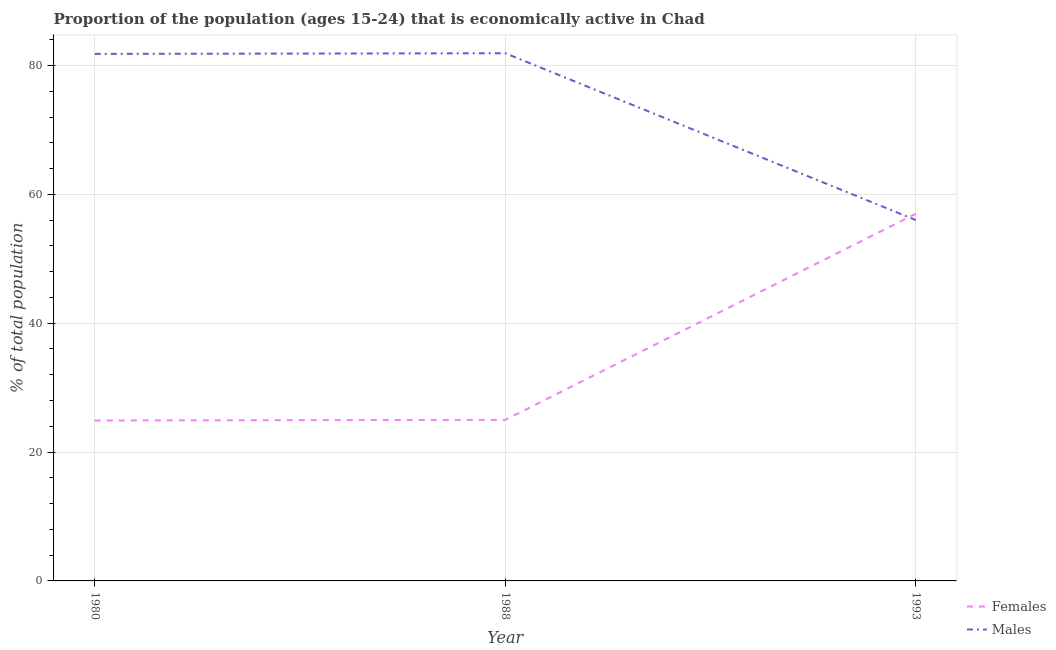Is the number of lines equal to the number of legend labels?
Provide a short and direct response. Yes. What is the percentage of economically active male population in 1980?
Offer a very short reply. 81.8. Across all years, what is the maximum percentage of economically active male population?
Provide a short and direct response. 81.9. Across all years, what is the minimum percentage of economically active male population?
Your response must be concise. 56. In which year was the percentage of economically active female population maximum?
Ensure brevity in your answer.  1993. In which year was the percentage of economically active male population minimum?
Keep it short and to the point. 1993. What is the total percentage of economically active male population in the graph?
Offer a terse response. 219.7. What is the difference between the percentage of economically active male population in 1980 and that in 1993?
Your answer should be very brief. 25.8. What is the difference between the percentage of economically active male population in 1980 and the percentage of economically active female population in 1993?
Offer a very short reply. 24.8. What is the average percentage of economically active female population per year?
Provide a short and direct response. 35.63. In how many years, is the percentage of economically active male population greater than 20 %?
Provide a short and direct response. 3. What is the ratio of the percentage of economically active male population in 1988 to that in 1993?
Provide a succinct answer. 1.46. What is the difference between the highest and the second highest percentage of economically active female population?
Ensure brevity in your answer.  32. What is the difference between the highest and the lowest percentage of economically active female population?
Your response must be concise. 32.1. In how many years, is the percentage of economically active female population greater than the average percentage of economically active female population taken over all years?
Offer a terse response. 1. Is the sum of the percentage of economically active female population in 1988 and 1993 greater than the maximum percentage of economically active male population across all years?
Offer a terse response. Yes. Does the percentage of economically active female population monotonically increase over the years?
Your answer should be compact. Yes. How many years are there in the graph?
Give a very brief answer. 3. What is the difference between two consecutive major ticks on the Y-axis?
Ensure brevity in your answer.  20. Are the values on the major ticks of Y-axis written in scientific E-notation?
Offer a very short reply. No. Does the graph contain grids?
Make the answer very short. Yes. How are the legend labels stacked?
Provide a short and direct response. Vertical. What is the title of the graph?
Offer a very short reply. Proportion of the population (ages 15-24) that is economically active in Chad. What is the label or title of the X-axis?
Ensure brevity in your answer.  Year. What is the label or title of the Y-axis?
Give a very brief answer. % of total population. What is the % of total population in Females in 1980?
Give a very brief answer. 24.9. What is the % of total population in Males in 1980?
Offer a very short reply. 81.8. What is the % of total population in Males in 1988?
Offer a terse response. 81.9. What is the % of total population in Females in 1993?
Offer a very short reply. 57. What is the % of total population in Males in 1993?
Ensure brevity in your answer.  56. Across all years, what is the maximum % of total population of Females?
Keep it short and to the point. 57. Across all years, what is the maximum % of total population in Males?
Provide a short and direct response. 81.9. Across all years, what is the minimum % of total population in Females?
Give a very brief answer. 24.9. Across all years, what is the minimum % of total population in Males?
Keep it short and to the point. 56. What is the total % of total population in Females in the graph?
Offer a very short reply. 106.9. What is the total % of total population of Males in the graph?
Provide a short and direct response. 219.7. What is the difference between the % of total population of Females in 1980 and that in 1988?
Provide a short and direct response. -0.1. What is the difference between the % of total population of Males in 1980 and that in 1988?
Offer a terse response. -0.1. What is the difference between the % of total population of Females in 1980 and that in 1993?
Your response must be concise. -32.1. What is the difference between the % of total population in Males in 1980 and that in 1993?
Give a very brief answer. 25.8. What is the difference between the % of total population of Females in 1988 and that in 1993?
Make the answer very short. -32. What is the difference between the % of total population in Males in 1988 and that in 1993?
Your answer should be compact. 25.9. What is the difference between the % of total population in Females in 1980 and the % of total population in Males in 1988?
Keep it short and to the point. -57. What is the difference between the % of total population in Females in 1980 and the % of total population in Males in 1993?
Your answer should be compact. -31.1. What is the difference between the % of total population in Females in 1988 and the % of total population in Males in 1993?
Your answer should be compact. -31. What is the average % of total population of Females per year?
Your answer should be very brief. 35.63. What is the average % of total population of Males per year?
Your answer should be compact. 73.23. In the year 1980, what is the difference between the % of total population of Females and % of total population of Males?
Your answer should be very brief. -56.9. In the year 1988, what is the difference between the % of total population in Females and % of total population in Males?
Keep it short and to the point. -56.9. What is the ratio of the % of total population in Males in 1980 to that in 1988?
Provide a succinct answer. 1. What is the ratio of the % of total population of Females in 1980 to that in 1993?
Make the answer very short. 0.44. What is the ratio of the % of total population in Males in 1980 to that in 1993?
Provide a succinct answer. 1.46. What is the ratio of the % of total population of Females in 1988 to that in 1993?
Offer a terse response. 0.44. What is the ratio of the % of total population in Males in 1988 to that in 1993?
Ensure brevity in your answer.  1.46. What is the difference between the highest and the second highest % of total population of Females?
Give a very brief answer. 32. What is the difference between the highest and the lowest % of total population in Females?
Your answer should be compact. 32.1. What is the difference between the highest and the lowest % of total population of Males?
Offer a terse response. 25.9. 